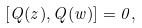<formula> <loc_0><loc_0><loc_500><loc_500>[ Q ( z ) , Q ( w ) ] = 0 ,</formula> 